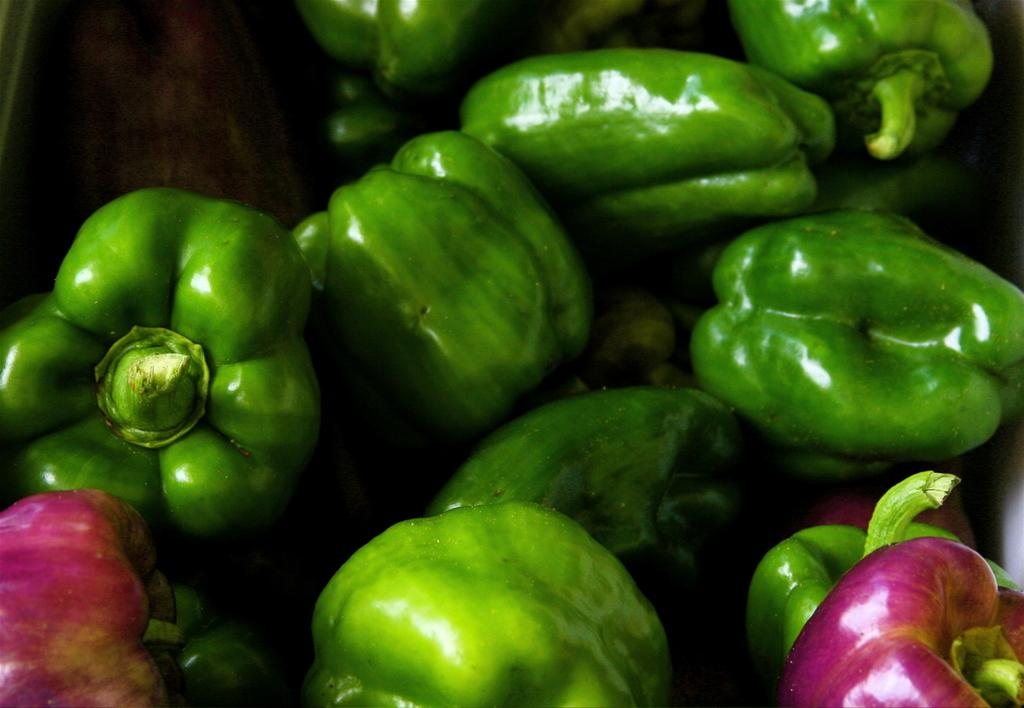What is the main subject of the image? The main subject of the image is vegetables. Where are the vegetables located in the image? The vegetables are in the center of the image. What type of letter is being written by the family in the image? There is no family or letter present in the image; it only features vegetables in the center. 